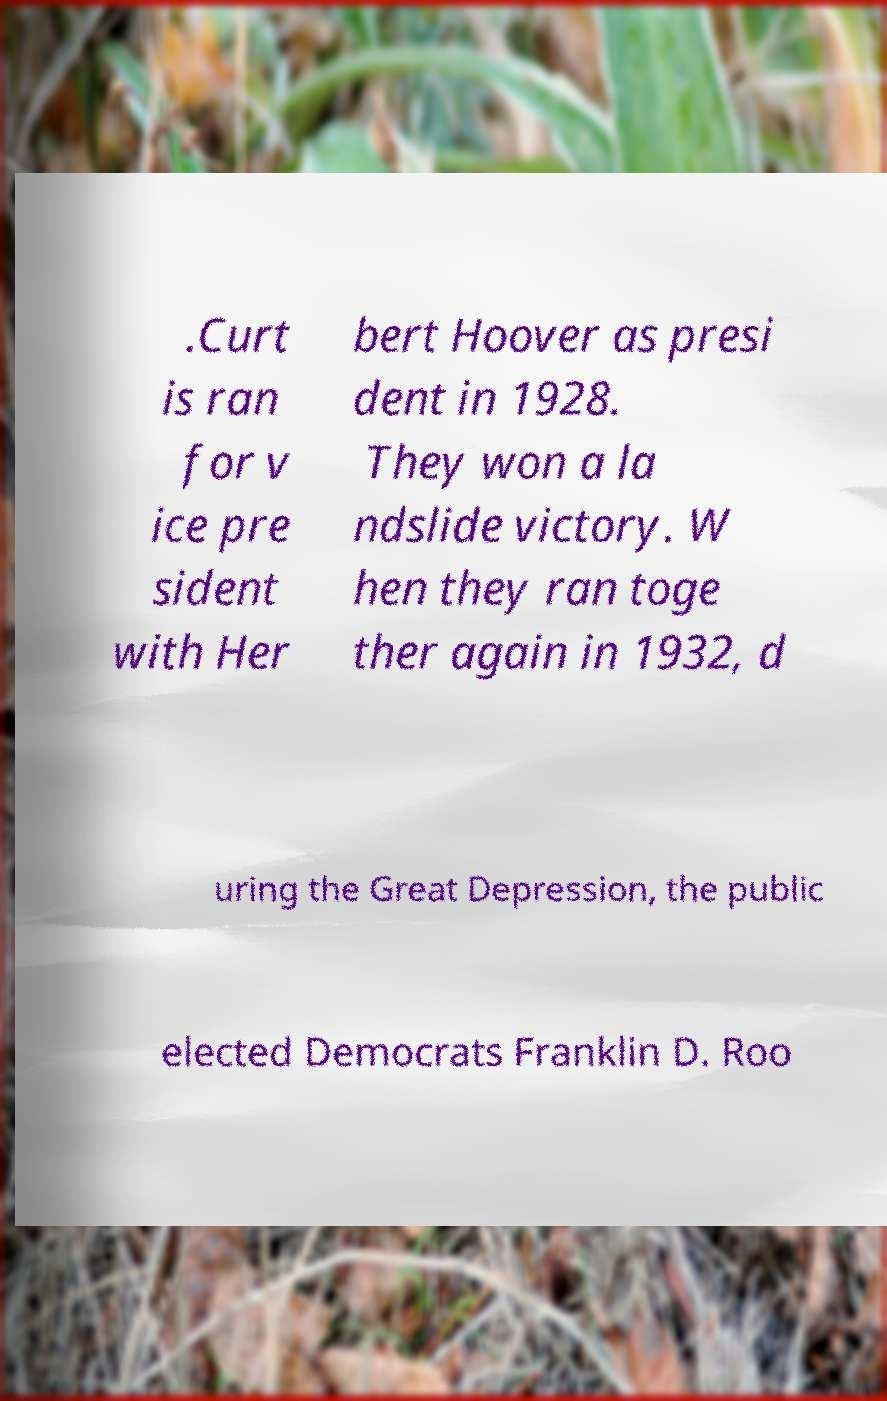Could you extract and type out the text from this image? .Curt is ran for v ice pre sident with Her bert Hoover as presi dent in 1928. They won a la ndslide victory. W hen they ran toge ther again in 1932, d uring the Great Depression, the public elected Democrats Franklin D. Roo 